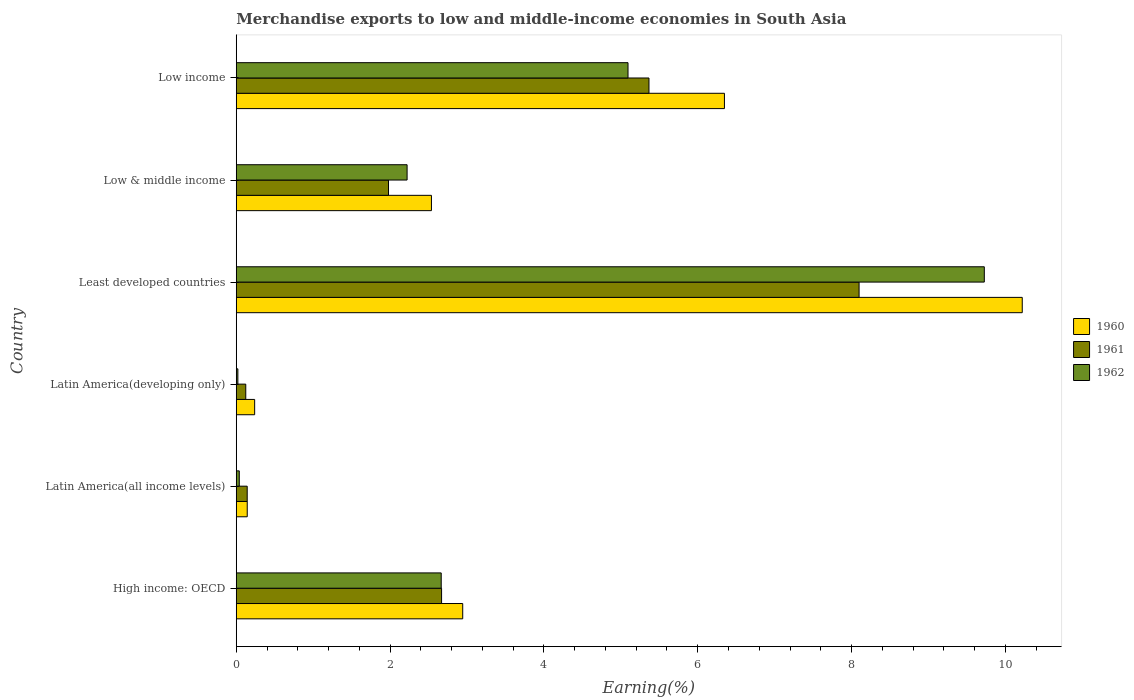How many groups of bars are there?
Your response must be concise. 6. Are the number of bars per tick equal to the number of legend labels?
Offer a very short reply. Yes. Are the number of bars on each tick of the Y-axis equal?
Make the answer very short. Yes. How many bars are there on the 2nd tick from the bottom?
Provide a succinct answer. 3. What is the label of the 1st group of bars from the top?
Your answer should be compact. Low income. What is the percentage of amount earned from merchandise exports in 1960 in Low & middle income?
Your answer should be very brief. 2.54. Across all countries, what is the maximum percentage of amount earned from merchandise exports in 1960?
Keep it short and to the point. 10.22. Across all countries, what is the minimum percentage of amount earned from merchandise exports in 1961?
Provide a short and direct response. 0.12. In which country was the percentage of amount earned from merchandise exports in 1962 maximum?
Make the answer very short. Least developed countries. In which country was the percentage of amount earned from merchandise exports in 1960 minimum?
Offer a very short reply. Latin America(all income levels). What is the total percentage of amount earned from merchandise exports in 1961 in the graph?
Provide a short and direct response. 18.38. What is the difference between the percentage of amount earned from merchandise exports in 1961 in High income: OECD and that in Latin America(developing only)?
Your answer should be compact. 2.55. What is the difference between the percentage of amount earned from merchandise exports in 1961 in Latin America(all income levels) and the percentage of amount earned from merchandise exports in 1960 in Low income?
Keep it short and to the point. -6.2. What is the average percentage of amount earned from merchandise exports in 1962 per country?
Provide a short and direct response. 3.29. What is the difference between the percentage of amount earned from merchandise exports in 1960 and percentage of amount earned from merchandise exports in 1961 in Latin America(developing only)?
Offer a terse response. 0.12. What is the ratio of the percentage of amount earned from merchandise exports in 1960 in Least developed countries to that in Low & middle income?
Offer a terse response. 4.03. Is the percentage of amount earned from merchandise exports in 1960 in Latin America(developing only) less than that in Low income?
Provide a short and direct response. Yes. Is the difference between the percentage of amount earned from merchandise exports in 1960 in Least developed countries and Low income greater than the difference between the percentage of amount earned from merchandise exports in 1961 in Least developed countries and Low income?
Your answer should be very brief. Yes. What is the difference between the highest and the second highest percentage of amount earned from merchandise exports in 1960?
Your response must be concise. 3.87. What is the difference between the highest and the lowest percentage of amount earned from merchandise exports in 1961?
Make the answer very short. 7.97. What does the 1st bar from the top in High income: OECD represents?
Your answer should be very brief. 1962. What does the 1st bar from the bottom in Low & middle income represents?
Your response must be concise. 1960. Are all the bars in the graph horizontal?
Your answer should be compact. Yes. How many countries are there in the graph?
Your response must be concise. 6. Does the graph contain any zero values?
Provide a short and direct response. No. Where does the legend appear in the graph?
Your answer should be compact. Center right. What is the title of the graph?
Offer a very short reply. Merchandise exports to low and middle-income economies in South Asia. What is the label or title of the X-axis?
Your answer should be compact. Earning(%). What is the Earning(%) of 1960 in High income: OECD?
Your answer should be very brief. 2.94. What is the Earning(%) of 1961 in High income: OECD?
Provide a short and direct response. 2.67. What is the Earning(%) of 1962 in High income: OECD?
Your answer should be compact. 2.66. What is the Earning(%) of 1960 in Latin America(all income levels)?
Your answer should be compact. 0.14. What is the Earning(%) in 1961 in Latin America(all income levels)?
Your answer should be very brief. 0.14. What is the Earning(%) in 1962 in Latin America(all income levels)?
Offer a terse response. 0.04. What is the Earning(%) in 1960 in Latin America(developing only)?
Offer a terse response. 0.24. What is the Earning(%) of 1961 in Latin America(developing only)?
Offer a very short reply. 0.12. What is the Earning(%) in 1962 in Latin America(developing only)?
Offer a very short reply. 0.02. What is the Earning(%) in 1960 in Least developed countries?
Provide a succinct answer. 10.22. What is the Earning(%) in 1961 in Least developed countries?
Your response must be concise. 8.1. What is the Earning(%) in 1962 in Least developed countries?
Give a very brief answer. 9.73. What is the Earning(%) of 1960 in Low & middle income?
Keep it short and to the point. 2.54. What is the Earning(%) in 1961 in Low & middle income?
Your answer should be very brief. 1.98. What is the Earning(%) in 1962 in Low & middle income?
Your response must be concise. 2.22. What is the Earning(%) in 1960 in Low income?
Your answer should be compact. 6.35. What is the Earning(%) of 1961 in Low income?
Give a very brief answer. 5.37. What is the Earning(%) in 1962 in Low income?
Your answer should be very brief. 5.09. Across all countries, what is the maximum Earning(%) in 1960?
Make the answer very short. 10.22. Across all countries, what is the maximum Earning(%) in 1961?
Ensure brevity in your answer.  8.1. Across all countries, what is the maximum Earning(%) of 1962?
Keep it short and to the point. 9.73. Across all countries, what is the minimum Earning(%) of 1960?
Provide a short and direct response. 0.14. Across all countries, what is the minimum Earning(%) of 1961?
Make the answer very short. 0.12. Across all countries, what is the minimum Earning(%) in 1962?
Your response must be concise. 0.02. What is the total Earning(%) of 1960 in the graph?
Provide a succinct answer. 22.43. What is the total Earning(%) in 1961 in the graph?
Make the answer very short. 18.38. What is the total Earning(%) in 1962 in the graph?
Your answer should be very brief. 19.77. What is the difference between the Earning(%) of 1960 in High income: OECD and that in Latin America(all income levels)?
Keep it short and to the point. 2.8. What is the difference between the Earning(%) in 1961 in High income: OECD and that in Latin America(all income levels)?
Make the answer very short. 2.53. What is the difference between the Earning(%) of 1962 in High income: OECD and that in Latin America(all income levels)?
Give a very brief answer. 2.63. What is the difference between the Earning(%) in 1960 in High income: OECD and that in Latin America(developing only)?
Ensure brevity in your answer.  2.71. What is the difference between the Earning(%) of 1961 in High income: OECD and that in Latin America(developing only)?
Ensure brevity in your answer.  2.55. What is the difference between the Earning(%) in 1962 in High income: OECD and that in Latin America(developing only)?
Give a very brief answer. 2.64. What is the difference between the Earning(%) of 1960 in High income: OECD and that in Least developed countries?
Your response must be concise. -7.27. What is the difference between the Earning(%) in 1961 in High income: OECD and that in Least developed countries?
Offer a very short reply. -5.43. What is the difference between the Earning(%) of 1962 in High income: OECD and that in Least developed countries?
Your response must be concise. -7.06. What is the difference between the Earning(%) in 1960 in High income: OECD and that in Low & middle income?
Your answer should be very brief. 0.41. What is the difference between the Earning(%) of 1961 in High income: OECD and that in Low & middle income?
Offer a very short reply. 0.69. What is the difference between the Earning(%) of 1962 in High income: OECD and that in Low & middle income?
Ensure brevity in your answer.  0.44. What is the difference between the Earning(%) in 1960 in High income: OECD and that in Low income?
Your answer should be compact. -3.4. What is the difference between the Earning(%) in 1961 in High income: OECD and that in Low income?
Keep it short and to the point. -2.7. What is the difference between the Earning(%) of 1962 in High income: OECD and that in Low income?
Your answer should be very brief. -2.43. What is the difference between the Earning(%) in 1960 in Latin America(all income levels) and that in Latin America(developing only)?
Offer a very short reply. -0.1. What is the difference between the Earning(%) in 1961 in Latin America(all income levels) and that in Latin America(developing only)?
Ensure brevity in your answer.  0.02. What is the difference between the Earning(%) of 1962 in Latin America(all income levels) and that in Latin America(developing only)?
Your answer should be compact. 0.02. What is the difference between the Earning(%) in 1960 in Latin America(all income levels) and that in Least developed countries?
Provide a succinct answer. -10.08. What is the difference between the Earning(%) of 1961 in Latin America(all income levels) and that in Least developed countries?
Give a very brief answer. -7.96. What is the difference between the Earning(%) in 1962 in Latin America(all income levels) and that in Least developed countries?
Offer a terse response. -9.69. What is the difference between the Earning(%) in 1960 in Latin America(all income levels) and that in Low & middle income?
Ensure brevity in your answer.  -2.39. What is the difference between the Earning(%) in 1961 in Latin America(all income levels) and that in Low & middle income?
Make the answer very short. -1.84. What is the difference between the Earning(%) in 1962 in Latin America(all income levels) and that in Low & middle income?
Your answer should be very brief. -2.18. What is the difference between the Earning(%) in 1960 in Latin America(all income levels) and that in Low income?
Offer a very short reply. -6.2. What is the difference between the Earning(%) of 1961 in Latin America(all income levels) and that in Low income?
Offer a terse response. -5.22. What is the difference between the Earning(%) of 1962 in Latin America(all income levels) and that in Low income?
Your answer should be compact. -5.05. What is the difference between the Earning(%) in 1960 in Latin America(developing only) and that in Least developed countries?
Make the answer very short. -9.98. What is the difference between the Earning(%) in 1961 in Latin America(developing only) and that in Least developed countries?
Give a very brief answer. -7.97. What is the difference between the Earning(%) of 1962 in Latin America(developing only) and that in Least developed countries?
Offer a terse response. -9.7. What is the difference between the Earning(%) of 1960 in Latin America(developing only) and that in Low & middle income?
Your answer should be compact. -2.3. What is the difference between the Earning(%) in 1961 in Latin America(developing only) and that in Low & middle income?
Your response must be concise. -1.86. What is the difference between the Earning(%) in 1962 in Latin America(developing only) and that in Low & middle income?
Make the answer very short. -2.2. What is the difference between the Earning(%) in 1960 in Latin America(developing only) and that in Low income?
Your answer should be very brief. -6.11. What is the difference between the Earning(%) in 1961 in Latin America(developing only) and that in Low income?
Make the answer very short. -5.24. What is the difference between the Earning(%) of 1962 in Latin America(developing only) and that in Low income?
Your response must be concise. -5.07. What is the difference between the Earning(%) in 1960 in Least developed countries and that in Low & middle income?
Give a very brief answer. 7.68. What is the difference between the Earning(%) in 1961 in Least developed countries and that in Low & middle income?
Keep it short and to the point. 6.12. What is the difference between the Earning(%) of 1962 in Least developed countries and that in Low & middle income?
Your response must be concise. 7.5. What is the difference between the Earning(%) in 1960 in Least developed countries and that in Low income?
Provide a succinct answer. 3.87. What is the difference between the Earning(%) in 1961 in Least developed countries and that in Low income?
Provide a succinct answer. 2.73. What is the difference between the Earning(%) of 1962 in Least developed countries and that in Low income?
Ensure brevity in your answer.  4.63. What is the difference between the Earning(%) of 1960 in Low & middle income and that in Low income?
Offer a terse response. -3.81. What is the difference between the Earning(%) of 1961 in Low & middle income and that in Low income?
Ensure brevity in your answer.  -3.39. What is the difference between the Earning(%) in 1962 in Low & middle income and that in Low income?
Provide a succinct answer. -2.87. What is the difference between the Earning(%) of 1960 in High income: OECD and the Earning(%) of 1961 in Latin America(all income levels)?
Your response must be concise. 2.8. What is the difference between the Earning(%) in 1960 in High income: OECD and the Earning(%) in 1962 in Latin America(all income levels)?
Offer a terse response. 2.91. What is the difference between the Earning(%) of 1961 in High income: OECD and the Earning(%) of 1962 in Latin America(all income levels)?
Ensure brevity in your answer.  2.63. What is the difference between the Earning(%) in 1960 in High income: OECD and the Earning(%) in 1961 in Latin America(developing only)?
Provide a succinct answer. 2.82. What is the difference between the Earning(%) in 1960 in High income: OECD and the Earning(%) in 1962 in Latin America(developing only)?
Provide a short and direct response. 2.92. What is the difference between the Earning(%) in 1961 in High income: OECD and the Earning(%) in 1962 in Latin America(developing only)?
Ensure brevity in your answer.  2.65. What is the difference between the Earning(%) of 1960 in High income: OECD and the Earning(%) of 1961 in Least developed countries?
Offer a very short reply. -5.15. What is the difference between the Earning(%) in 1960 in High income: OECD and the Earning(%) in 1962 in Least developed countries?
Your answer should be very brief. -6.78. What is the difference between the Earning(%) of 1961 in High income: OECD and the Earning(%) of 1962 in Least developed countries?
Your answer should be compact. -7.06. What is the difference between the Earning(%) in 1960 in High income: OECD and the Earning(%) in 1962 in Low & middle income?
Offer a very short reply. 0.72. What is the difference between the Earning(%) in 1961 in High income: OECD and the Earning(%) in 1962 in Low & middle income?
Offer a terse response. 0.45. What is the difference between the Earning(%) in 1960 in High income: OECD and the Earning(%) in 1961 in Low income?
Your response must be concise. -2.42. What is the difference between the Earning(%) in 1960 in High income: OECD and the Earning(%) in 1962 in Low income?
Your answer should be compact. -2.15. What is the difference between the Earning(%) in 1961 in High income: OECD and the Earning(%) in 1962 in Low income?
Keep it short and to the point. -2.42. What is the difference between the Earning(%) of 1960 in Latin America(all income levels) and the Earning(%) of 1961 in Latin America(developing only)?
Offer a very short reply. 0.02. What is the difference between the Earning(%) in 1960 in Latin America(all income levels) and the Earning(%) in 1962 in Latin America(developing only)?
Give a very brief answer. 0.12. What is the difference between the Earning(%) of 1961 in Latin America(all income levels) and the Earning(%) of 1962 in Latin America(developing only)?
Keep it short and to the point. 0.12. What is the difference between the Earning(%) in 1960 in Latin America(all income levels) and the Earning(%) in 1961 in Least developed countries?
Provide a short and direct response. -7.96. What is the difference between the Earning(%) of 1960 in Latin America(all income levels) and the Earning(%) of 1962 in Least developed countries?
Provide a succinct answer. -9.58. What is the difference between the Earning(%) in 1961 in Latin America(all income levels) and the Earning(%) in 1962 in Least developed countries?
Offer a terse response. -9.58. What is the difference between the Earning(%) in 1960 in Latin America(all income levels) and the Earning(%) in 1961 in Low & middle income?
Provide a succinct answer. -1.84. What is the difference between the Earning(%) in 1960 in Latin America(all income levels) and the Earning(%) in 1962 in Low & middle income?
Keep it short and to the point. -2.08. What is the difference between the Earning(%) of 1961 in Latin America(all income levels) and the Earning(%) of 1962 in Low & middle income?
Your response must be concise. -2.08. What is the difference between the Earning(%) of 1960 in Latin America(all income levels) and the Earning(%) of 1961 in Low income?
Provide a short and direct response. -5.22. What is the difference between the Earning(%) of 1960 in Latin America(all income levels) and the Earning(%) of 1962 in Low income?
Your answer should be compact. -4.95. What is the difference between the Earning(%) of 1961 in Latin America(all income levels) and the Earning(%) of 1962 in Low income?
Make the answer very short. -4.95. What is the difference between the Earning(%) in 1960 in Latin America(developing only) and the Earning(%) in 1961 in Least developed countries?
Provide a succinct answer. -7.86. What is the difference between the Earning(%) in 1960 in Latin America(developing only) and the Earning(%) in 1962 in Least developed countries?
Keep it short and to the point. -9.49. What is the difference between the Earning(%) in 1961 in Latin America(developing only) and the Earning(%) in 1962 in Least developed countries?
Offer a very short reply. -9.6. What is the difference between the Earning(%) of 1960 in Latin America(developing only) and the Earning(%) of 1961 in Low & middle income?
Give a very brief answer. -1.74. What is the difference between the Earning(%) of 1960 in Latin America(developing only) and the Earning(%) of 1962 in Low & middle income?
Offer a terse response. -1.98. What is the difference between the Earning(%) in 1961 in Latin America(developing only) and the Earning(%) in 1962 in Low & middle income?
Your answer should be very brief. -2.1. What is the difference between the Earning(%) of 1960 in Latin America(developing only) and the Earning(%) of 1961 in Low income?
Provide a succinct answer. -5.13. What is the difference between the Earning(%) in 1960 in Latin America(developing only) and the Earning(%) in 1962 in Low income?
Keep it short and to the point. -4.85. What is the difference between the Earning(%) of 1961 in Latin America(developing only) and the Earning(%) of 1962 in Low income?
Provide a succinct answer. -4.97. What is the difference between the Earning(%) of 1960 in Least developed countries and the Earning(%) of 1961 in Low & middle income?
Provide a short and direct response. 8.24. What is the difference between the Earning(%) in 1960 in Least developed countries and the Earning(%) in 1962 in Low & middle income?
Your answer should be very brief. 8. What is the difference between the Earning(%) in 1961 in Least developed countries and the Earning(%) in 1962 in Low & middle income?
Provide a succinct answer. 5.88. What is the difference between the Earning(%) of 1960 in Least developed countries and the Earning(%) of 1961 in Low income?
Offer a very short reply. 4.85. What is the difference between the Earning(%) in 1960 in Least developed countries and the Earning(%) in 1962 in Low income?
Make the answer very short. 5.13. What is the difference between the Earning(%) in 1961 in Least developed countries and the Earning(%) in 1962 in Low income?
Your answer should be compact. 3. What is the difference between the Earning(%) in 1960 in Low & middle income and the Earning(%) in 1961 in Low income?
Provide a short and direct response. -2.83. What is the difference between the Earning(%) of 1960 in Low & middle income and the Earning(%) of 1962 in Low income?
Your response must be concise. -2.56. What is the difference between the Earning(%) of 1961 in Low & middle income and the Earning(%) of 1962 in Low income?
Provide a short and direct response. -3.11. What is the average Earning(%) in 1960 per country?
Give a very brief answer. 3.74. What is the average Earning(%) in 1961 per country?
Your answer should be compact. 3.06. What is the average Earning(%) of 1962 per country?
Keep it short and to the point. 3.29. What is the difference between the Earning(%) of 1960 and Earning(%) of 1961 in High income: OECD?
Offer a very short reply. 0.27. What is the difference between the Earning(%) in 1960 and Earning(%) in 1962 in High income: OECD?
Offer a terse response. 0.28. What is the difference between the Earning(%) of 1961 and Earning(%) of 1962 in High income: OECD?
Give a very brief answer. 0. What is the difference between the Earning(%) of 1960 and Earning(%) of 1961 in Latin America(all income levels)?
Ensure brevity in your answer.  0. What is the difference between the Earning(%) in 1960 and Earning(%) in 1962 in Latin America(all income levels)?
Keep it short and to the point. 0.1. What is the difference between the Earning(%) in 1961 and Earning(%) in 1962 in Latin America(all income levels)?
Your answer should be compact. 0.1. What is the difference between the Earning(%) of 1960 and Earning(%) of 1961 in Latin America(developing only)?
Offer a terse response. 0.12. What is the difference between the Earning(%) of 1960 and Earning(%) of 1962 in Latin America(developing only)?
Ensure brevity in your answer.  0.22. What is the difference between the Earning(%) of 1961 and Earning(%) of 1962 in Latin America(developing only)?
Provide a short and direct response. 0.1. What is the difference between the Earning(%) of 1960 and Earning(%) of 1961 in Least developed countries?
Your answer should be compact. 2.12. What is the difference between the Earning(%) in 1960 and Earning(%) in 1962 in Least developed countries?
Keep it short and to the point. 0.49. What is the difference between the Earning(%) of 1961 and Earning(%) of 1962 in Least developed countries?
Ensure brevity in your answer.  -1.63. What is the difference between the Earning(%) in 1960 and Earning(%) in 1961 in Low & middle income?
Give a very brief answer. 0.56. What is the difference between the Earning(%) of 1960 and Earning(%) of 1962 in Low & middle income?
Ensure brevity in your answer.  0.32. What is the difference between the Earning(%) in 1961 and Earning(%) in 1962 in Low & middle income?
Offer a terse response. -0.24. What is the difference between the Earning(%) of 1960 and Earning(%) of 1961 in Low income?
Offer a terse response. 0.98. What is the difference between the Earning(%) of 1960 and Earning(%) of 1962 in Low income?
Offer a very short reply. 1.25. What is the difference between the Earning(%) in 1961 and Earning(%) in 1962 in Low income?
Provide a succinct answer. 0.27. What is the ratio of the Earning(%) of 1960 in High income: OECD to that in Latin America(all income levels)?
Ensure brevity in your answer.  20.64. What is the ratio of the Earning(%) in 1961 in High income: OECD to that in Latin America(all income levels)?
Your answer should be very brief. 18.74. What is the ratio of the Earning(%) of 1962 in High income: OECD to that in Latin America(all income levels)?
Your answer should be very brief. 67.77. What is the ratio of the Earning(%) of 1960 in High income: OECD to that in Latin America(developing only)?
Your answer should be very brief. 12.31. What is the ratio of the Earning(%) in 1961 in High income: OECD to that in Latin America(developing only)?
Your response must be concise. 21.58. What is the ratio of the Earning(%) of 1962 in High income: OECD to that in Latin America(developing only)?
Give a very brief answer. 127.02. What is the ratio of the Earning(%) of 1960 in High income: OECD to that in Least developed countries?
Your response must be concise. 0.29. What is the ratio of the Earning(%) of 1961 in High income: OECD to that in Least developed countries?
Provide a succinct answer. 0.33. What is the ratio of the Earning(%) in 1962 in High income: OECD to that in Least developed countries?
Your answer should be very brief. 0.27. What is the ratio of the Earning(%) in 1960 in High income: OECD to that in Low & middle income?
Your answer should be compact. 1.16. What is the ratio of the Earning(%) in 1961 in High income: OECD to that in Low & middle income?
Provide a succinct answer. 1.35. What is the ratio of the Earning(%) of 1962 in High income: OECD to that in Low & middle income?
Your response must be concise. 1.2. What is the ratio of the Earning(%) of 1960 in High income: OECD to that in Low income?
Provide a succinct answer. 0.46. What is the ratio of the Earning(%) in 1961 in High income: OECD to that in Low income?
Ensure brevity in your answer.  0.5. What is the ratio of the Earning(%) of 1962 in High income: OECD to that in Low income?
Your response must be concise. 0.52. What is the ratio of the Earning(%) in 1960 in Latin America(all income levels) to that in Latin America(developing only)?
Keep it short and to the point. 0.6. What is the ratio of the Earning(%) in 1961 in Latin America(all income levels) to that in Latin America(developing only)?
Your answer should be compact. 1.15. What is the ratio of the Earning(%) of 1962 in Latin America(all income levels) to that in Latin America(developing only)?
Make the answer very short. 1.87. What is the ratio of the Earning(%) of 1960 in Latin America(all income levels) to that in Least developed countries?
Provide a succinct answer. 0.01. What is the ratio of the Earning(%) of 1961 in Latin America(all income levels) to that in Least developed countries?
Ensure brevity in your answer.  0.02. What is the ratio of the Earning(%) in 1962 in Latin America(all income levels) to that in Least developed countries?
Give a very brief answer. 0. What is the ratio of the Earning(%) in 1960 in Latin America(all income levels) to that in Low & middle income?
Keep it short and to the point. 0.06. What is the ratio of the Earning(%) of 1961 in Latin America(all income levels) to that in Low & middle income?
Your answer should be very brief. 0.07. What is the ratio of the Earning(%) of 1962 in Latin America(all income levels) to that in Low & middle income?
Your answer should be very brief. 0.02. What is the ratio of the Earning(%) of 1960 in Latin America(all income levels) to that in Low income?
Offer a terse response. 0.02. What is the ratio of the Earning(%) of 1961 in Latin America(all income levels) to that in Low income?
Ensure brevity in your answer.  0.03. What is the ratio of the Earning(%) in 1962 in Latin America(all income levels) to that in Low income?
Keep it short and to the point. 0.01. What is the ratio of the Earning(%) in 1960 in Latin America(developing only) to that in Least developed countries?
Ensure brevity in your answer.  0.02. What is the ratio of the Earning(%) of 1961 in Latin America(developing only) to that in Least developed countries?
Provide a succinct answer. 0.02. What is the ratio of the Earning(%) of 1962 in Latin America(developing only) to that in Least developed countries?
Your answer should be very brief. 0. What is the ratio of the Earning(%) of 1960 in Latin America(developing only) to that in Low & middle income?
Offer a very short reply. 0.09. What is the ratio of the Earning(%) of 1961 in Latin America(developing only) to that in Low & middle income?
Give a very brief answer. 0.06. What is the ratio of the Earning(%) of 1962 in Latin America(developing only) to that in Low & middle income?
Offer a terse response. 0.01. What is the ratio of the Earning(%) of 1960 in Latin America(developing only) to that in Low income?
Ensure brevity in your answer.  0.04. What is the ratio of the Earning(%) of 1961 in Latin America(developing only) to that in Low income?
Offer a very short reply. 0.02. What is the ratio of the Earning(%) in 1962 in Latin America(developing only) to that in Low income?
Ensure brevity in your answer.  0. What is the ratio of the Earning(%) of 1960 in Least developed countries to that in Low & middle income?
Your answer should be very brief. 4.03. What is the ratio of the Earning(%) in 1961 in Least developed countries to that in Low & middle income?
Keep it short and to the point. 4.09. What is the ratio of the Earning(%) in 1962 in Least developed countries to that in Low & middle income?
Offer a very short reply. 4.38. What is the ratio of the Earning(%) of 1960 in Least developed countries to that in Low income?
Provide a succinct answer. 1.61. What is the ratio of the Earning(%) in 1961 in Least developed countries to that in Low income?
Ensure brevity in your answer.  1.51. What is the ratio of the Earning(%) of 1962 in Least developed countries to that in Low income?
Provide a succinct answer. 1.91. What is the ratio of the Earning(%) in 1960 in Low & middle income to that in Low income?
Your response must be concise. 0.4. What is the ratio of the Earning(%) of 1961 in Low & middle income to that in Low income?
Make the answer very short. 0.37. What is the ratio of the Earning(%) in 1962 in Low & middle income to that in Low income?
Your answer should be compact. 0.44. What is the difference between the highest and the second highest Earning(%) in 1960?
Make the answer very short. 3.87. What is the difference between the highest and the second highest Earning(%) in 1961?
Provide a succinct answer. 2.73. What is the difference between the highest and the second highest Earning(%) in 1962?
Offer a terse response. 4.63. What is the difference between the highest and the lowest Earning(%) in 1960?
Offer a terse response. 10.08. What is the difference between the highest and the lowest Earning(%) in 1961?
Keep it short and to the point. 7.97. What is the difference between the highest and the lowest Earning(%) of 1962?
Ensure brevity in your answer.  9.7. 